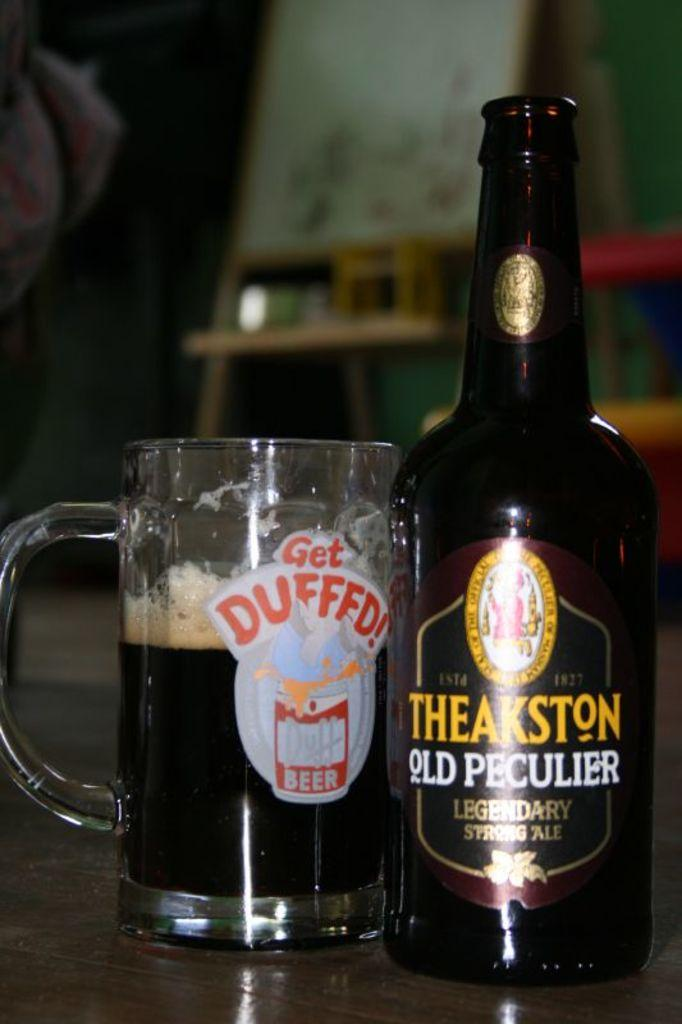<image>
Relay a brief, clear account of the picture shown. A glass that reads Get Duffed and a bottle of beer. 